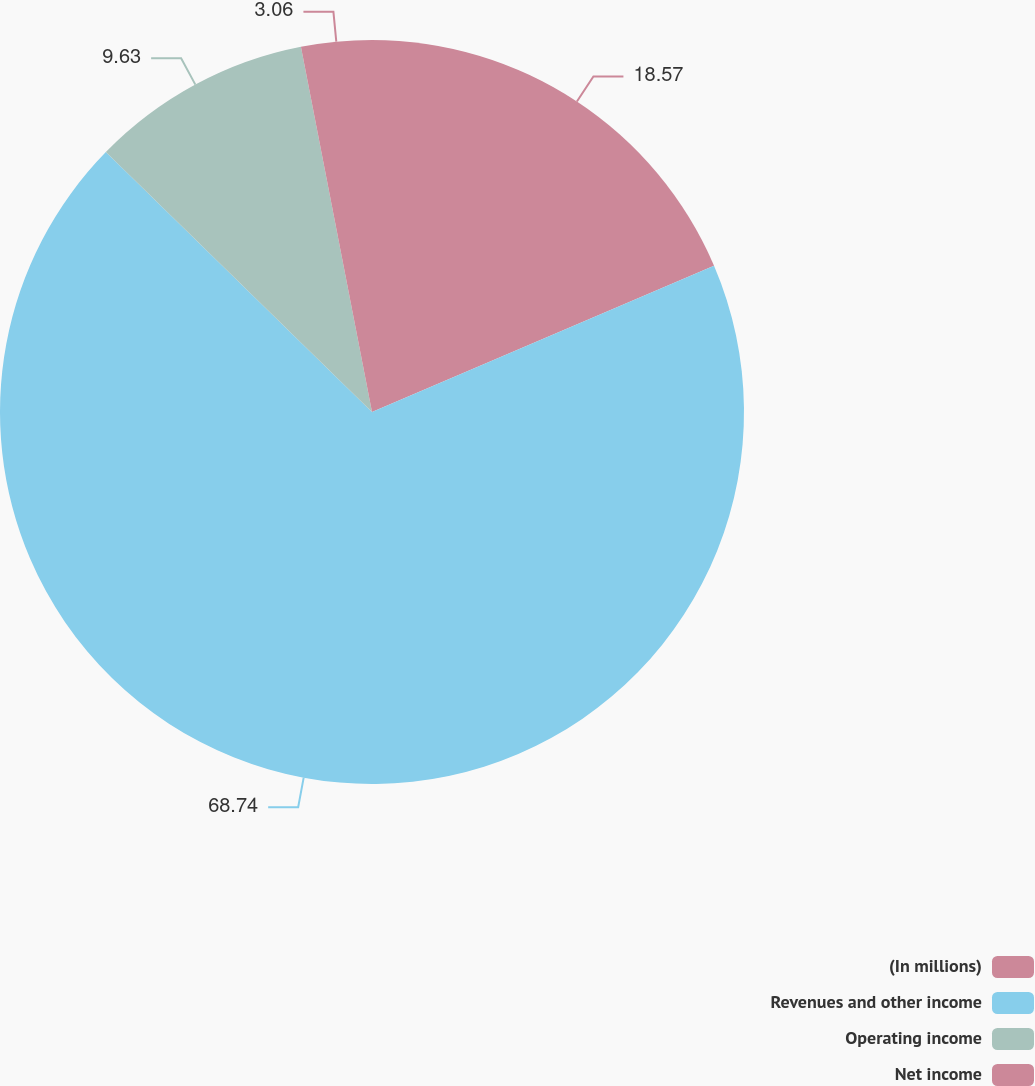<chart> <loc_0><loc_0><loc_500><loc_500><pie_chart><fcel>(In millions)<fcel>Revenues and other income<fcel>Operating income<fcel>Net income<nl><fcel>18.57%<fcel>68.75%<fcel>9.63%<fcel>3.06%<nl></chart> 